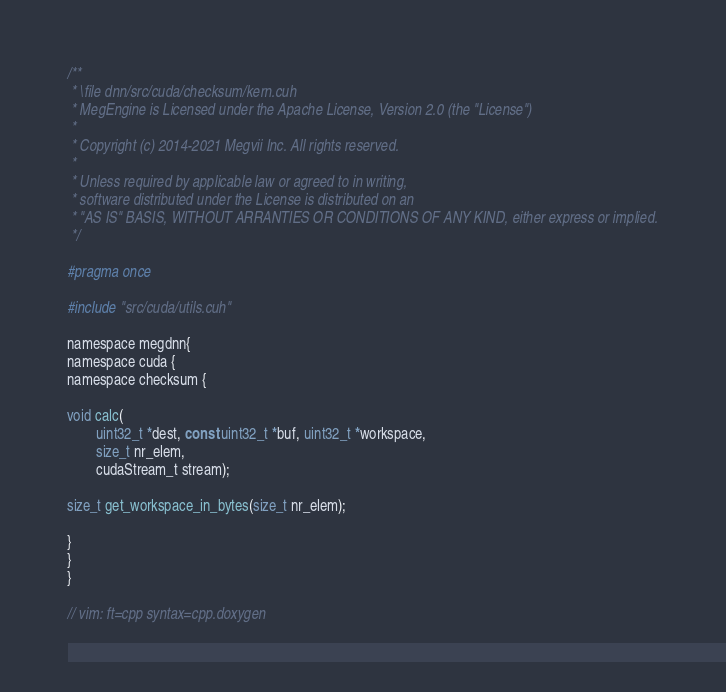<code> <loc_0><loc_0><loc_500><loc_500><_Cuda_>/**
 * \file dnn/src/cuda/checksum/kern.cuh
 * MegEngine is Licensed under the Apache License, Version 2.0 (the "License")
 *
 * Copyright (c) 2014-2021 Megvii Inc. All rights reserved.
 *
 * Unless required by applicable law or agreed to in writing,
 * software distributed under the License is distributed on an
 * "AS IS" BASIS, WITHOUT ARRANTIES OR CONDITIONS OF ANY KIND, either express or implied.
 */

#pragma once

#include "src/cuda/utils.cuh"

namespace megdnn{
namespace cuda {
namespace checksum {

void calc(
        uint32_t *dest, const uint32_t *buf, uint32_t *workspace,
        size_t nr_elem,
        cudaStream_t stream);

size_t get_workspace_in_bytes(size_t nr_elem);

}
}
}

// vim: ft=cpp syntax=cpp.doxygen

</code> 